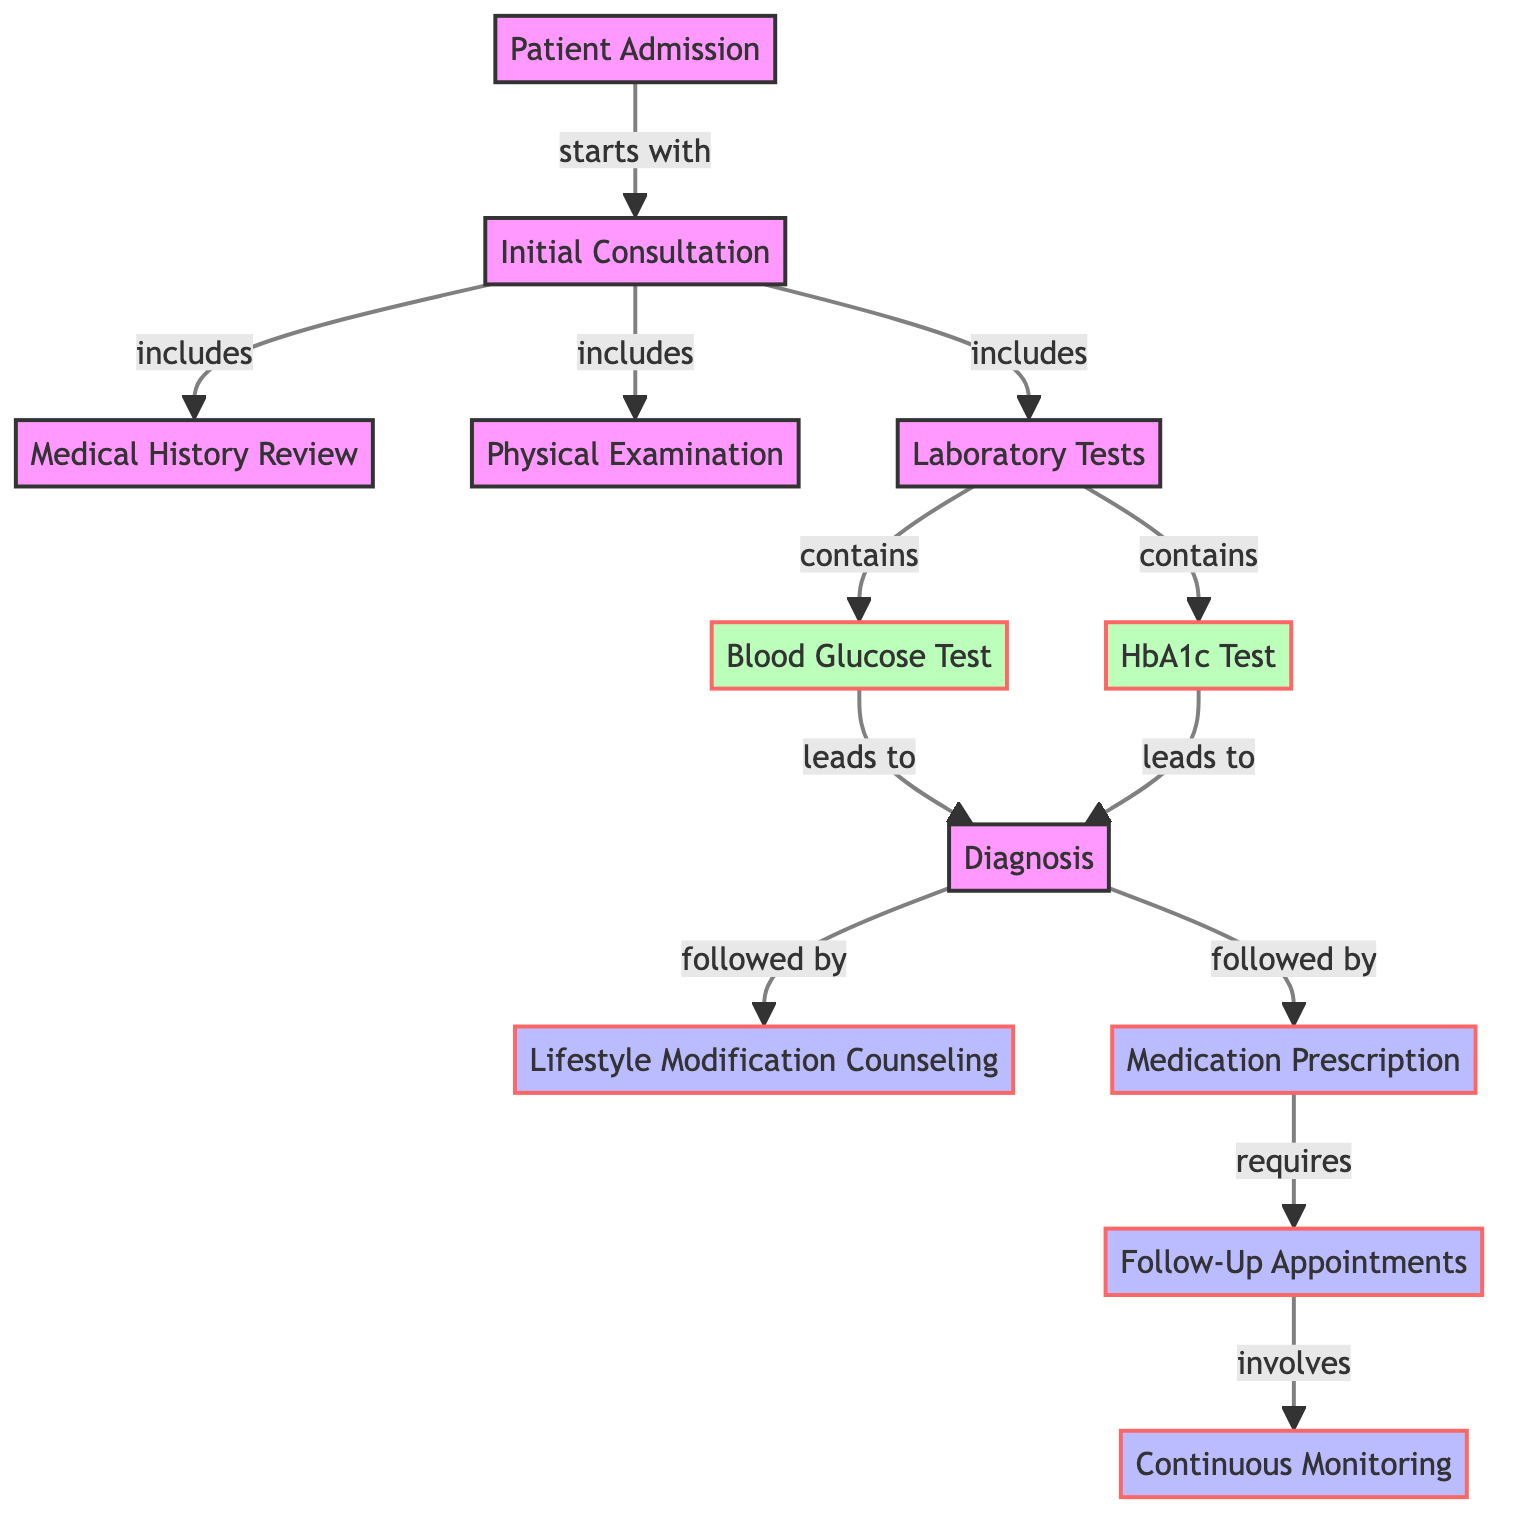What is the starting point of the process? The directed graph indicates that the process starts with the "Patient Admission" node, identified by edge labeled "starts with." Therefore, the initial step in diagnosing and treating a common illness is patient admission.
Answer: Patient Admission How many total nodes are in the diagram? The diagram contains a total of 12 nodes, which are the various steps and processes involved in diagnosing and treating Type 2 Diabetes.
Answer: 12 What is the first medical test conducted after laboratory tests? According to the directed graph, the "Blood Glucose Test" is listed first following the "Laboratory Tests" node, indicated by the edge labeled "contains."
Answer: Blood Glucose Test Which two tests lead to the diagnosis? The edges from both the "Blood Glucose Test" and the "HbA1c Test" point to the "Diagnosis" node, showing that both tests are crucial for diagnosing Type 2 Diabetes.
Answer: Blood Glucose Test and HbA1c Test What processes follow the diagnosis? Following the "Diagnosis" node, there are two processes indicated: "Lifestyle Modification Counseling" and "Medication Prescription," connected by the edges labeled "followed by."
Answer: Lifestyle Modification Counseling and Medication Prescription What is required after medication prescription? The directed edge from "Medication Prescription" to "Follow-Up Appointments," labeled "requires," clearly states what is mandated next after prescribing medication.
Answer: Follow-Up Appointments Which step involves continuous patient care? The final node connected to "Follow-Up Appointments," indicating that continuous patient care is addressed in the "Continuous Monitoring" step, as shown by the edge labeled "involves."
Answer: Continuous Monitoring How many tests are performed during the laboratory tests step? There are two tests mentioned that come from the "Laboratory Tests" node, which include the "Blood Glucose Test" and the "HbA1c Test," as indicated by the edges labeled "contains."
Answer: 2 What step comes before the physical examination? The directed graph illustrates that "Medical History Review" is listed as part of the "Initial Consultation" node, preceding the "Physical Examination" node, as indicated by the edges labeled "includes."
Answer: Medical History Review 